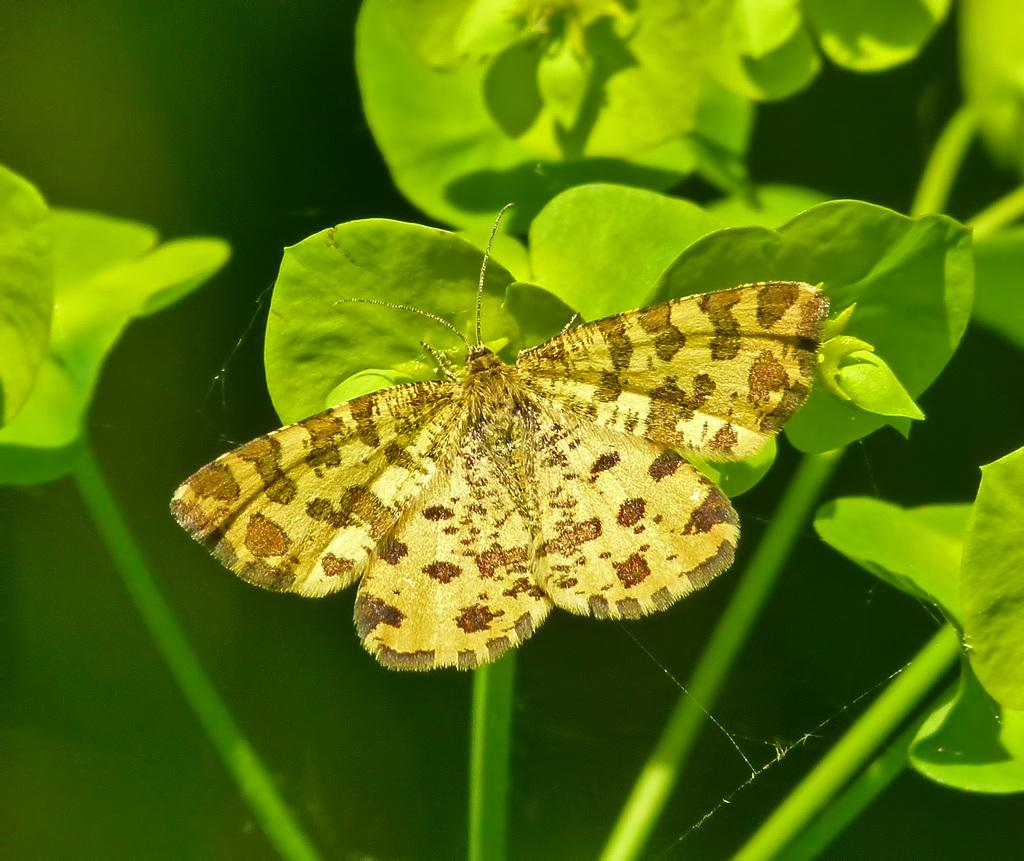What is the main subject of the image? There is a butterfly on a leaf in the image. What else can be seen on the leaf? There are leaves in the image. What other elements are present in the image? There are stems and webs visible. How would you describe the background of the image? The background has a blurred view. What type of liquid can be seen dripping from the butterfly's wings in the image? There is no liquid dripping from the butterfly's wings in the image. How many rings are visible on the butterfly's body in the image? There are no rings visible on the butterfly's body in the image. 